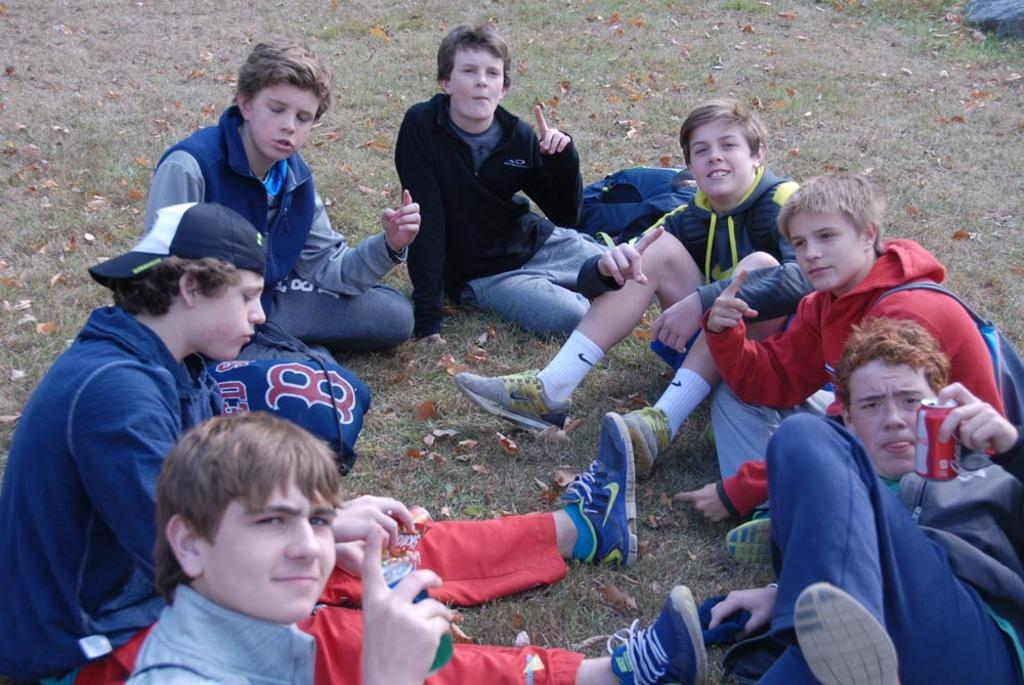Who is present in the image? There are children in the image. What are the children wearing? The children are wearing different color dresses. Where are the children located? The children are on the grass. What can be seen on the ground in the image? There are dry leaves on the ground. What is visible in the background of the image? There is an object in the background of the image. What is the price of the clam in the image? There is no clam present in the image, so it is not possible to determine its price. 